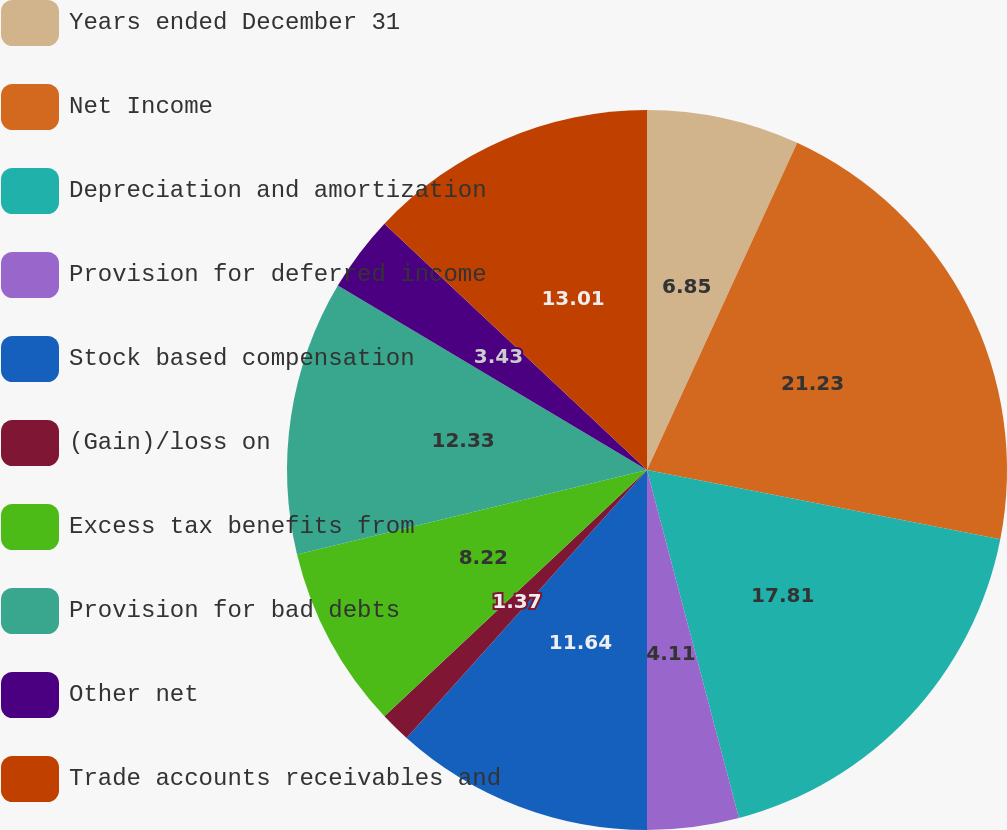<chart> <loc_0><loc_0><loc_500><loc_500><pie_chart><fcel>Years ended December 31<fcel>Net Income<fcel>Depreciation and amortization<fcel>Provision for deferred income<fcel>Stock based compensation<fcel>(Gain)/loss on<fcel>Excess tax benefits from<fcel>Provision for bad debts<fcel>Other net<fcel>Trade accounts receivables and<nl><fcel>6.85%<fcel>21.23%<fcel>17.81%<fcel>4.11%<fcel>11.64%<fcel>1.37%<fcel>8.22%<fcel>12.33%<fcel>3.43%<fcel>13.01%<nl></chart> 